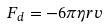Convert formula to latex. <formula><loc_0><loc_0><loc_500><loc_500>F _ { d } = - 6 \pi \eta r v</formula> 